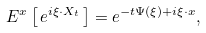Convert formula to latex. <formula><loc_0><loc_0><loc_500><loc_500>E ^ { x } \left [ \, e ^ { i \xi \cdot X _ { t } } \, \right ] = e ^ { - t \Psi ( \xi ) + i \xi \cdot x } ,</formula> 